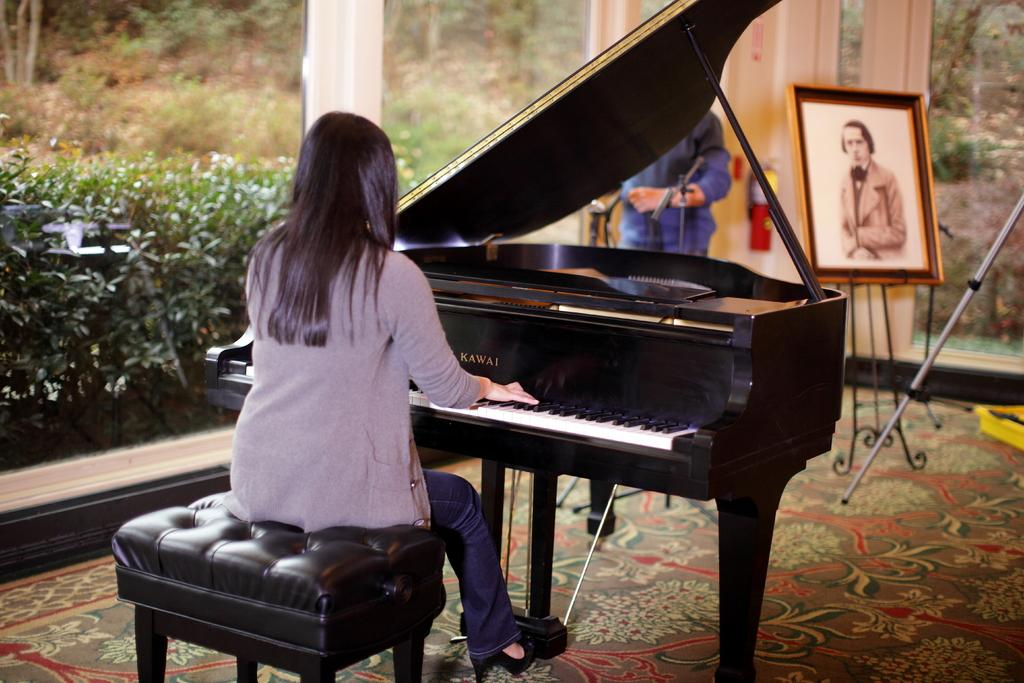Who is the main subject in the image? There is a woman in the image. What is the woman doing in the image? The woman is seated on a stool and playing a piano. Is there anyone else in the image besides the woman? Yes, there is a man standing in the image. Can you describe any other objects in the image? There is a photo frame in the image. What type of sweater is the woman wearing in the image? The image does not show the woman wearing a sweater, so it cannot be determined from the image. 